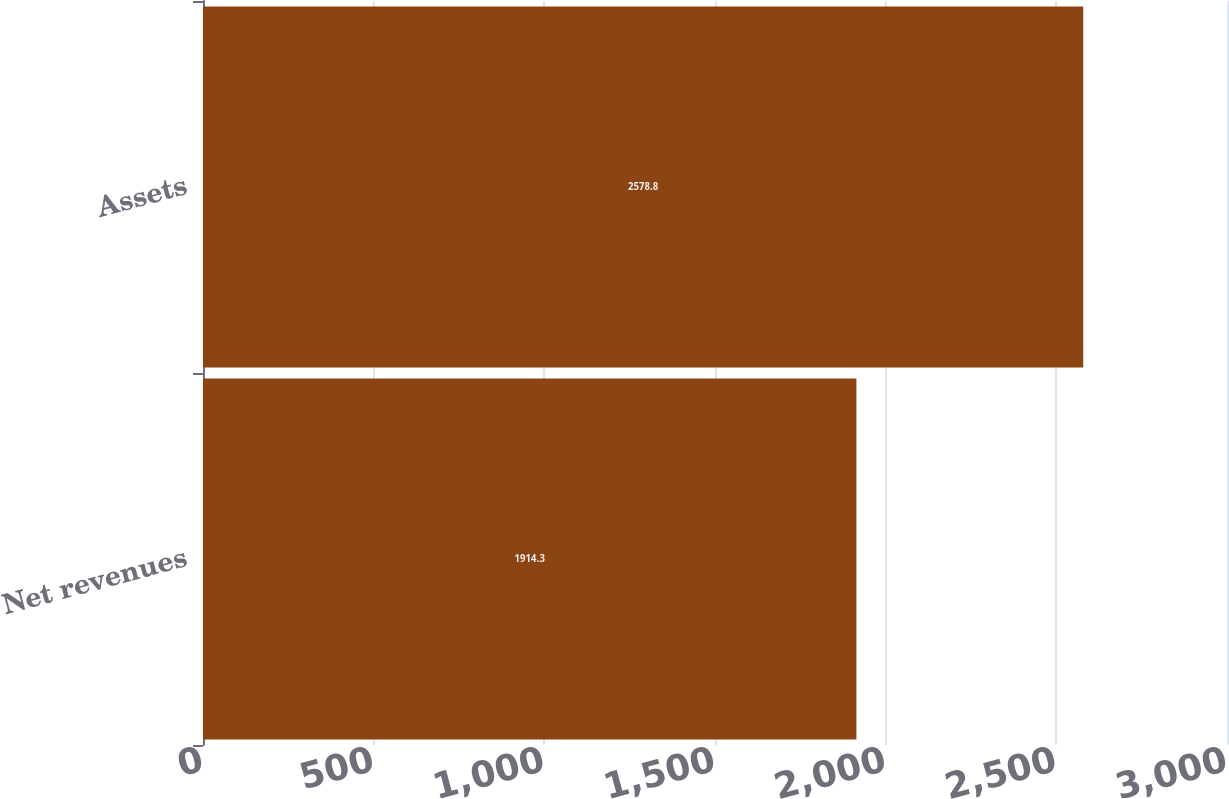Convert chart. <chart><loc_0><loc_0><loc_500><loc_500><bar_chart><fcel>Net revenues<fcel>Assets<nl><fcel>1914.3<fcel>2578.8<nl></chart> 